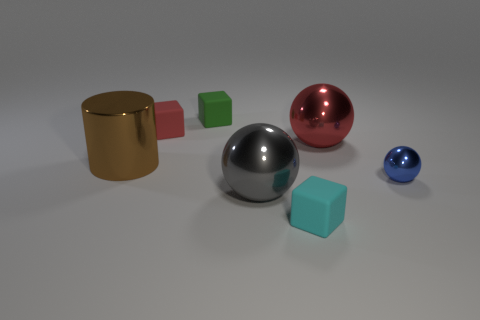Are there more tiny blocks than brown metallic things?
Give a very brief answer. Yes. What is the size of the shiny sphere that is left of the rubber cube in front of the red thing that is on the left side of the big red ball?
Make the answer very short. Large. There is a red metal sphere; does it have the same size as the ball in front of the small shiny thing?
Your response must be concise. Yes. Is the number of small matte things that are on the left side of the tiny green matte thing less than the number of small green things?
Give a very brief answer. No. What number of small spheres are the same color as the large metal cylinder?
Your answer should be compact. 0. Are there fewer tiny green matte cubes than purple metal balls?
Provide a short and direct response. No. Are the tiny blue object and the big red sphere made of the same material?
Keep it short and to the point. Yes. How many other objects are the same size as the brown object?
Your response must be concise. 2. There is a matte thing in front of the metallic object left of the red matte cube; what is its color?
Your response must be concise. Cyan. What number of other objects are the same shape as the tiny red object?
Provide a succinct answer. 2. 